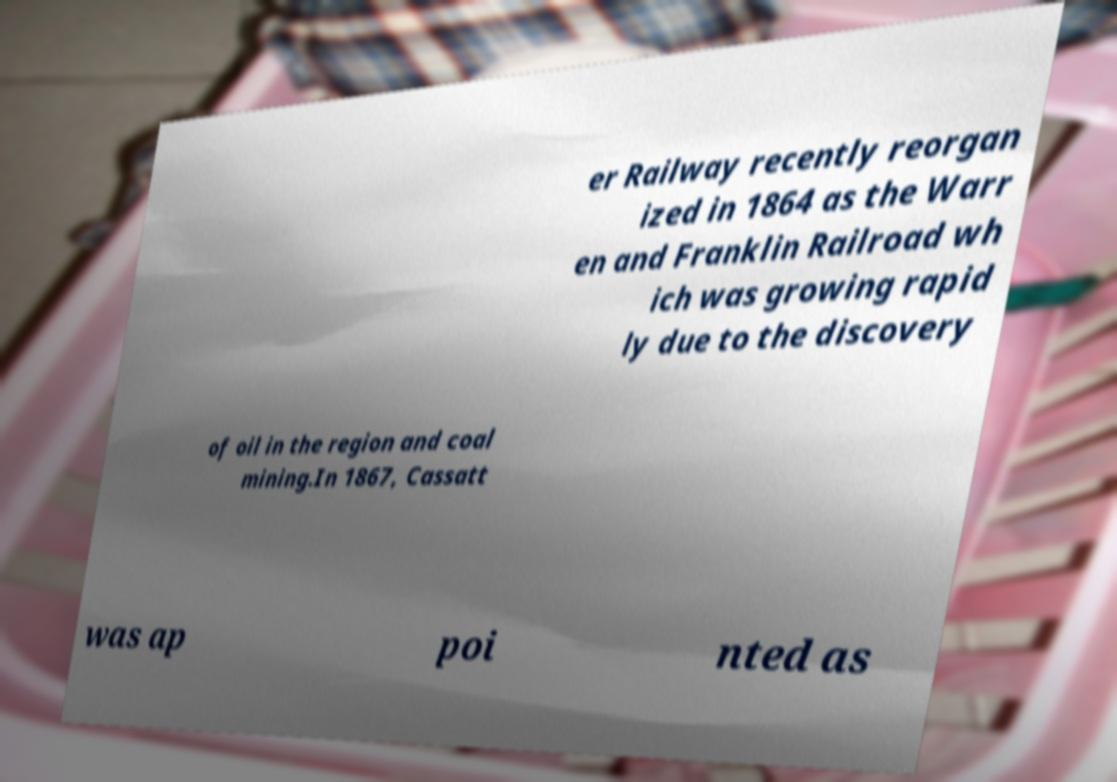I need the written content from this picture converted into text. Can you do that? er Railway recently reorgan ized in 1864 as the Warr en and Franklin Railroad wh ich was growing rapid ly due to the discovery of oil in the region and coal mining.In 1867, Cassatt was ap poi nted as 